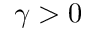Convert formula to latex. <formula><loc_0><loc_0><loc_500><loc_500>\gamma > 0</formula> 